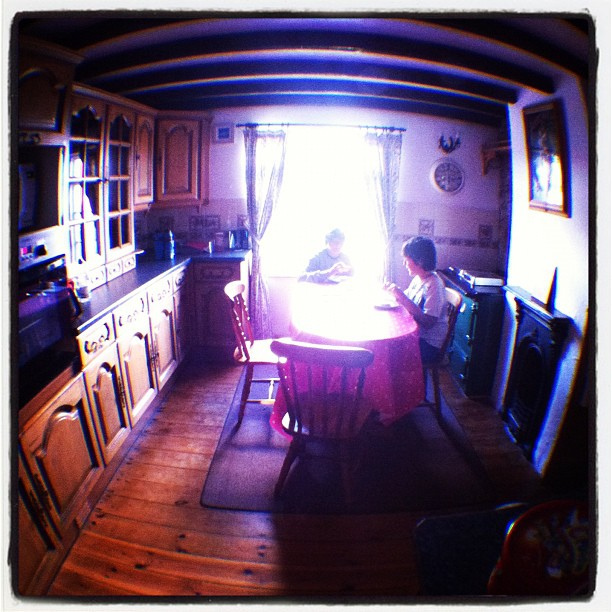How many chairs are visible? 2 